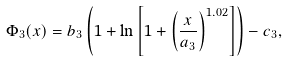Convert formula to latex. <formula><loc_0><loc_0><loc_500><loc_500>\Phi _ { 3 } ( x ) = b _ { 3 } \left ( 1 + \ln \left [ 1 + \left ( \frac { x } { a _ { 3 } } \right ) ^ { 1 . 0 2 } \right ] \right ) - c _ { 3 } ,</formula> 